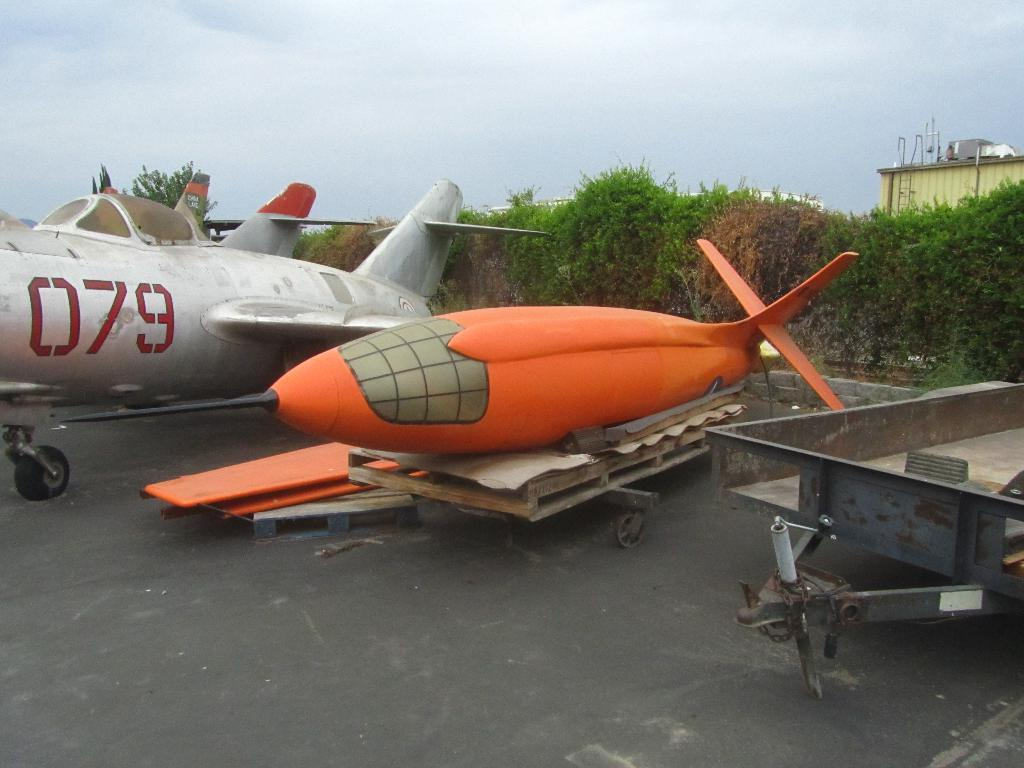<image>
Give a short and clear explanation of the subsequent image. A silver plane with the number 079 sits next to an orange glider. 